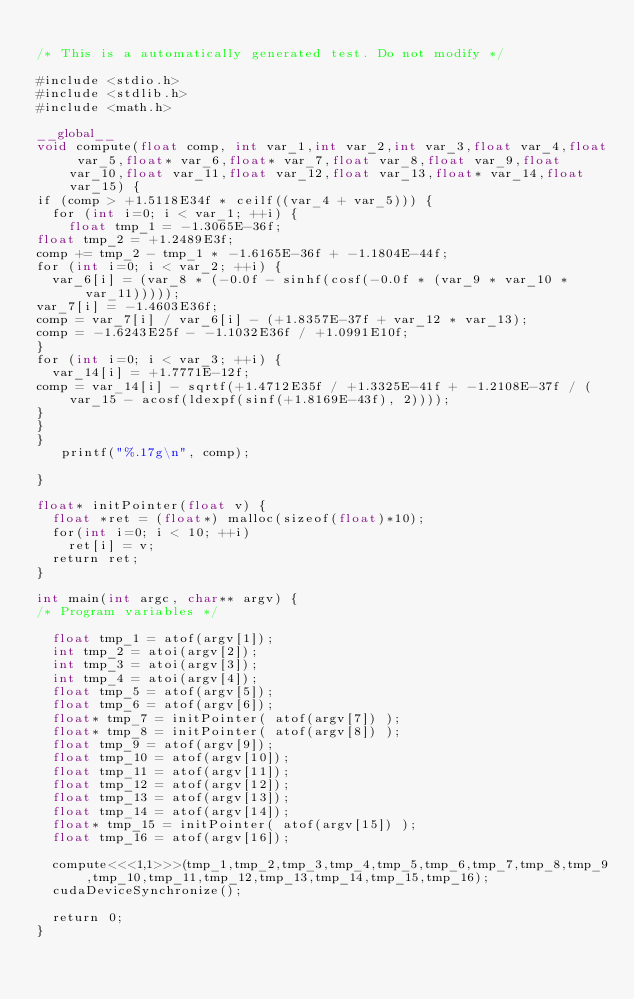<code> <loc_0><loc_0><loc_500><loc_500><_Cuda_>
/* This is a automatically generated test. Do not modify */

#include <stdio.h>
#include <stdlib.h>
#include <math.h>

__global__
void compute(float comp, int var_1,int var_2,int var_3,float var_4,float var_5,float* var_6,float* var_7,float var_8,float var_9,float var_10,float var_11,float var_12,float var_13,float* var_14,float var_15) {
if (comp > +1.5118E34f * ceilf((var_4 + var_5))) {
  for (int i=0; i < var_1; ++i) {
    float tmp_1 = -1.3065E-36f;
float tmp_2 = +1.2489E3f;
comp += tmp_2 - tmp_1 * -1.6165E-36f + -1.1804E-44f;
for (int i=0; i < var_2; ++i) {
  var_6[i] = (var_8 * (-0.0f - sinhf(cosf(-0.0f * (var_9 * var_10 * var_11)))));
var_7[i] = -1.4603E36f;
comp = var_7[i] / var_6[i] - (+1.8357E-37f + var_12 * var_13);
comp = -1.6243E25f - -1.1032E36f / +1.0991E10f;
}
for (int i=0; i < var_3; ++i) {
  var_14[i] = +1.7771E-12f;
comp = var_14[i] - sqrtf(+1.4712E35f / +1.3325E-41f + -1.2108E-37f / (var_15 - acosf(ldexpf(sinf(+1.8169E-43f), 2))));
}
}
}
   printf("%.17g\n", comp);

}

float* initPointer(float v) {
  float *ret = (float*) malloc(sizeof(float)*10);
  for(int i=0; i < 10; ++i)
    ret[i] = v;
  return ret;
}

int main(int argc, char** argv) {
/* Program variables */

  float tmp_1 = atof(argv[1]);
  int tmp_2 = atoi(argv[2]);
  int tmp_3 = atoi(argv[3]);
  int tmp_4 = atoi(argv[4]);
  float tmp_5 = atof(argv[5]);
  float tmp_6 = atof(argv[6]);
  float* tmp_7 = initPointer( atof(argv[7]) );
  float* tmp_8 = initPointer( atof(argv[8]) );
  float tmp_9 = atof(argv[9]);
  float tmp_10 = atof(argv[10]);
  float tmp_11 = atof(argv[11]);
  float tmp_12 = atof(argv[12]);
  float tmp_13 = atof(argv[13]);
  float tmp_14 = atof(argv[14]);
  float* tmp_15 = initPointer( atof(argv[15]) );
  float tmp_16 = atof(argv[16]);

  compute<<<1,1>>>(tmp_1,tmp_2,tmp_3,tmp_4,tmp_5,tmp_6,tmp_7,tmp_8,tmp_9,tmp_10,tmp_11,tmp_12,tmp_13,tmp_14,tmp_15,tmp_16);
  cudaDeviceSynchronize();

  return 0;
}
</code> 